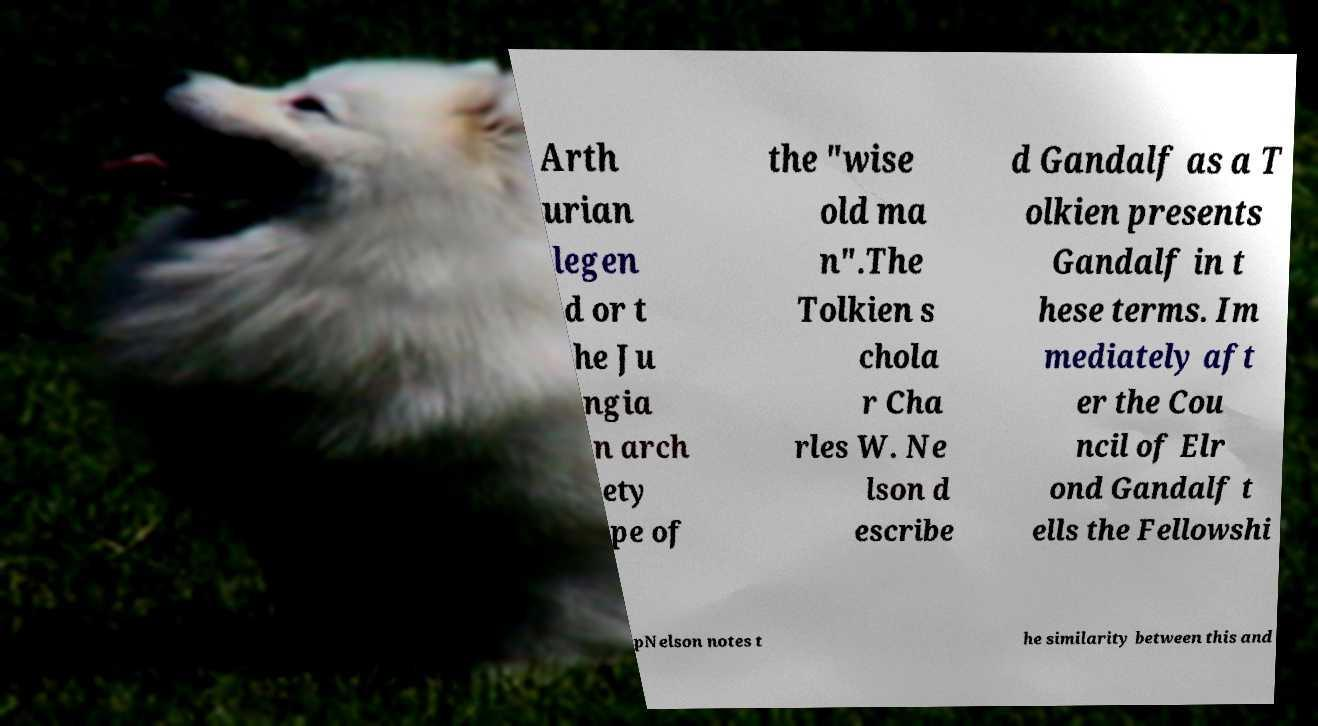Can you read and provide the text displayed in the image?This photo seems to have some interesting text. Can you extract and type it out for me? Arth urian legen d or t he Ju ngia n arch ety pe of the "wise old ma n".The Tolkien s chola r Cha rles W. Ne lson d escribe d Gandalf as a T olkien presents Gandalf in t hese terms. Im mediately aft er the Cou ncil of Elr ond Gandalf t ells the Fellowshi pNelson notes t he similarity between this and 